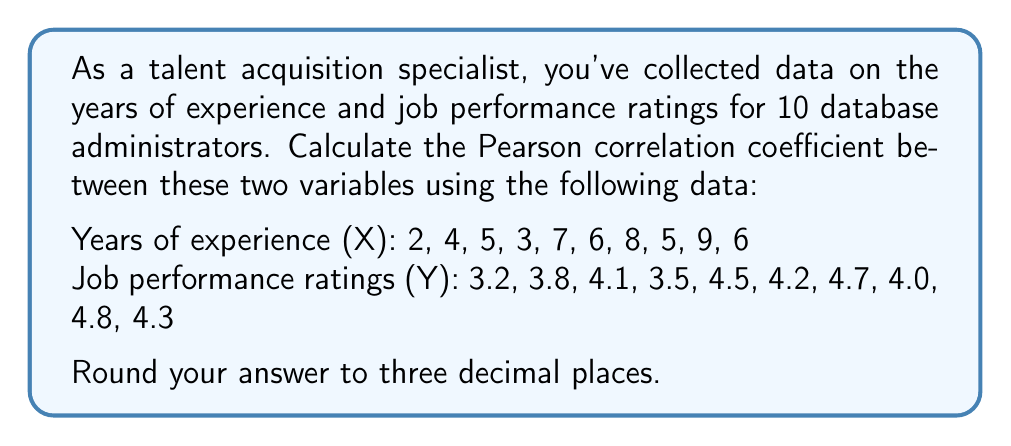Help me with this question. To calculate the Pearson correlation coefficient (r), we'll use the formula:

$$ r = \frac{n\sum xy - \sum x \sum y}{\sqrt{[n\sum x^2 - (\sum x)^2][n\sum y^2 - (\sum y)^2]}} $$

Step 1: Calculate the sums and squared sums:
$\sum x = 55$
$\sum y = 41.1$
$\sum x^2 = 349$
$\sum y^2 = 170.87$
$\sum xy = 232.7$
$n = 10$

Step 2: Calculate the numerator:
$n\sum xy - \sum x \sum y = 10(232.7) - 55(41.1) = 2327 - 2260.5 = 66.5$

Step 3: Calculate the denominator:
$\sqrt{[n\sum x^2 - (\sum x)^2][n\sum y^2 - (\sum y)^2]}$
$= \sqrt{[10(349) - 55^2][10(170.87) - 41.1^2]}$
$= \sqrt{[3490 - 3025][1708.7 - 1689.21]}$
$= \sqrt{465 * 19.49}$
$= \sqrt{9062.85}$
$= 95.20$

Step 4: Divide the numerator by the denominator:
$r = \frac{66.5}{95.20} = 0.698$

Step 5: Round to three decimal places:
$r \approx 0.698$
Answer: 0.698 